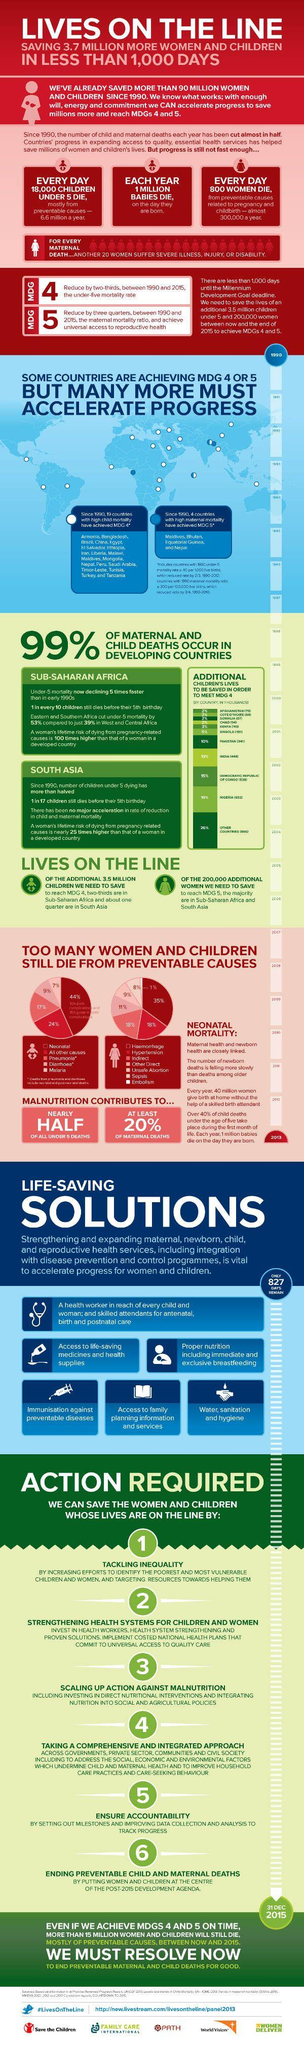Highlight a few significant elements in this photo. The death rate of children under 5 in South Asia is 1 in 17. According to recent studies, only 20% of maternal deaths are caused by malnutrition. The program aimed at improving maternal health and promoting gender equality is called MDG 5, which stands for Millennium Development Goal 5. Each year, approximately 800 women are dying due to maternity and childbirth related issues. The death rate of pregnant women and newborn babies in developing countries is a significant concern, with statistics indicating a high inverse percentage compared to developed countries. 